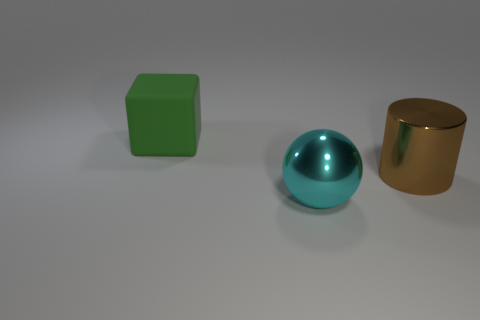Add 2 yellow metal cylinders. How many objects exist? 5 Subtract all cylinders. How many objects are left? 2 Add 1 big spheres. How many big spheres are left? 2 Add 1 large brown blocks. How many large brown blocks exist? 1 Subtract 0 purple cubes. How many objects are left? 3 Subtract all big gray shiny objects. Subtract all large spheres. How many objects are left? 2 